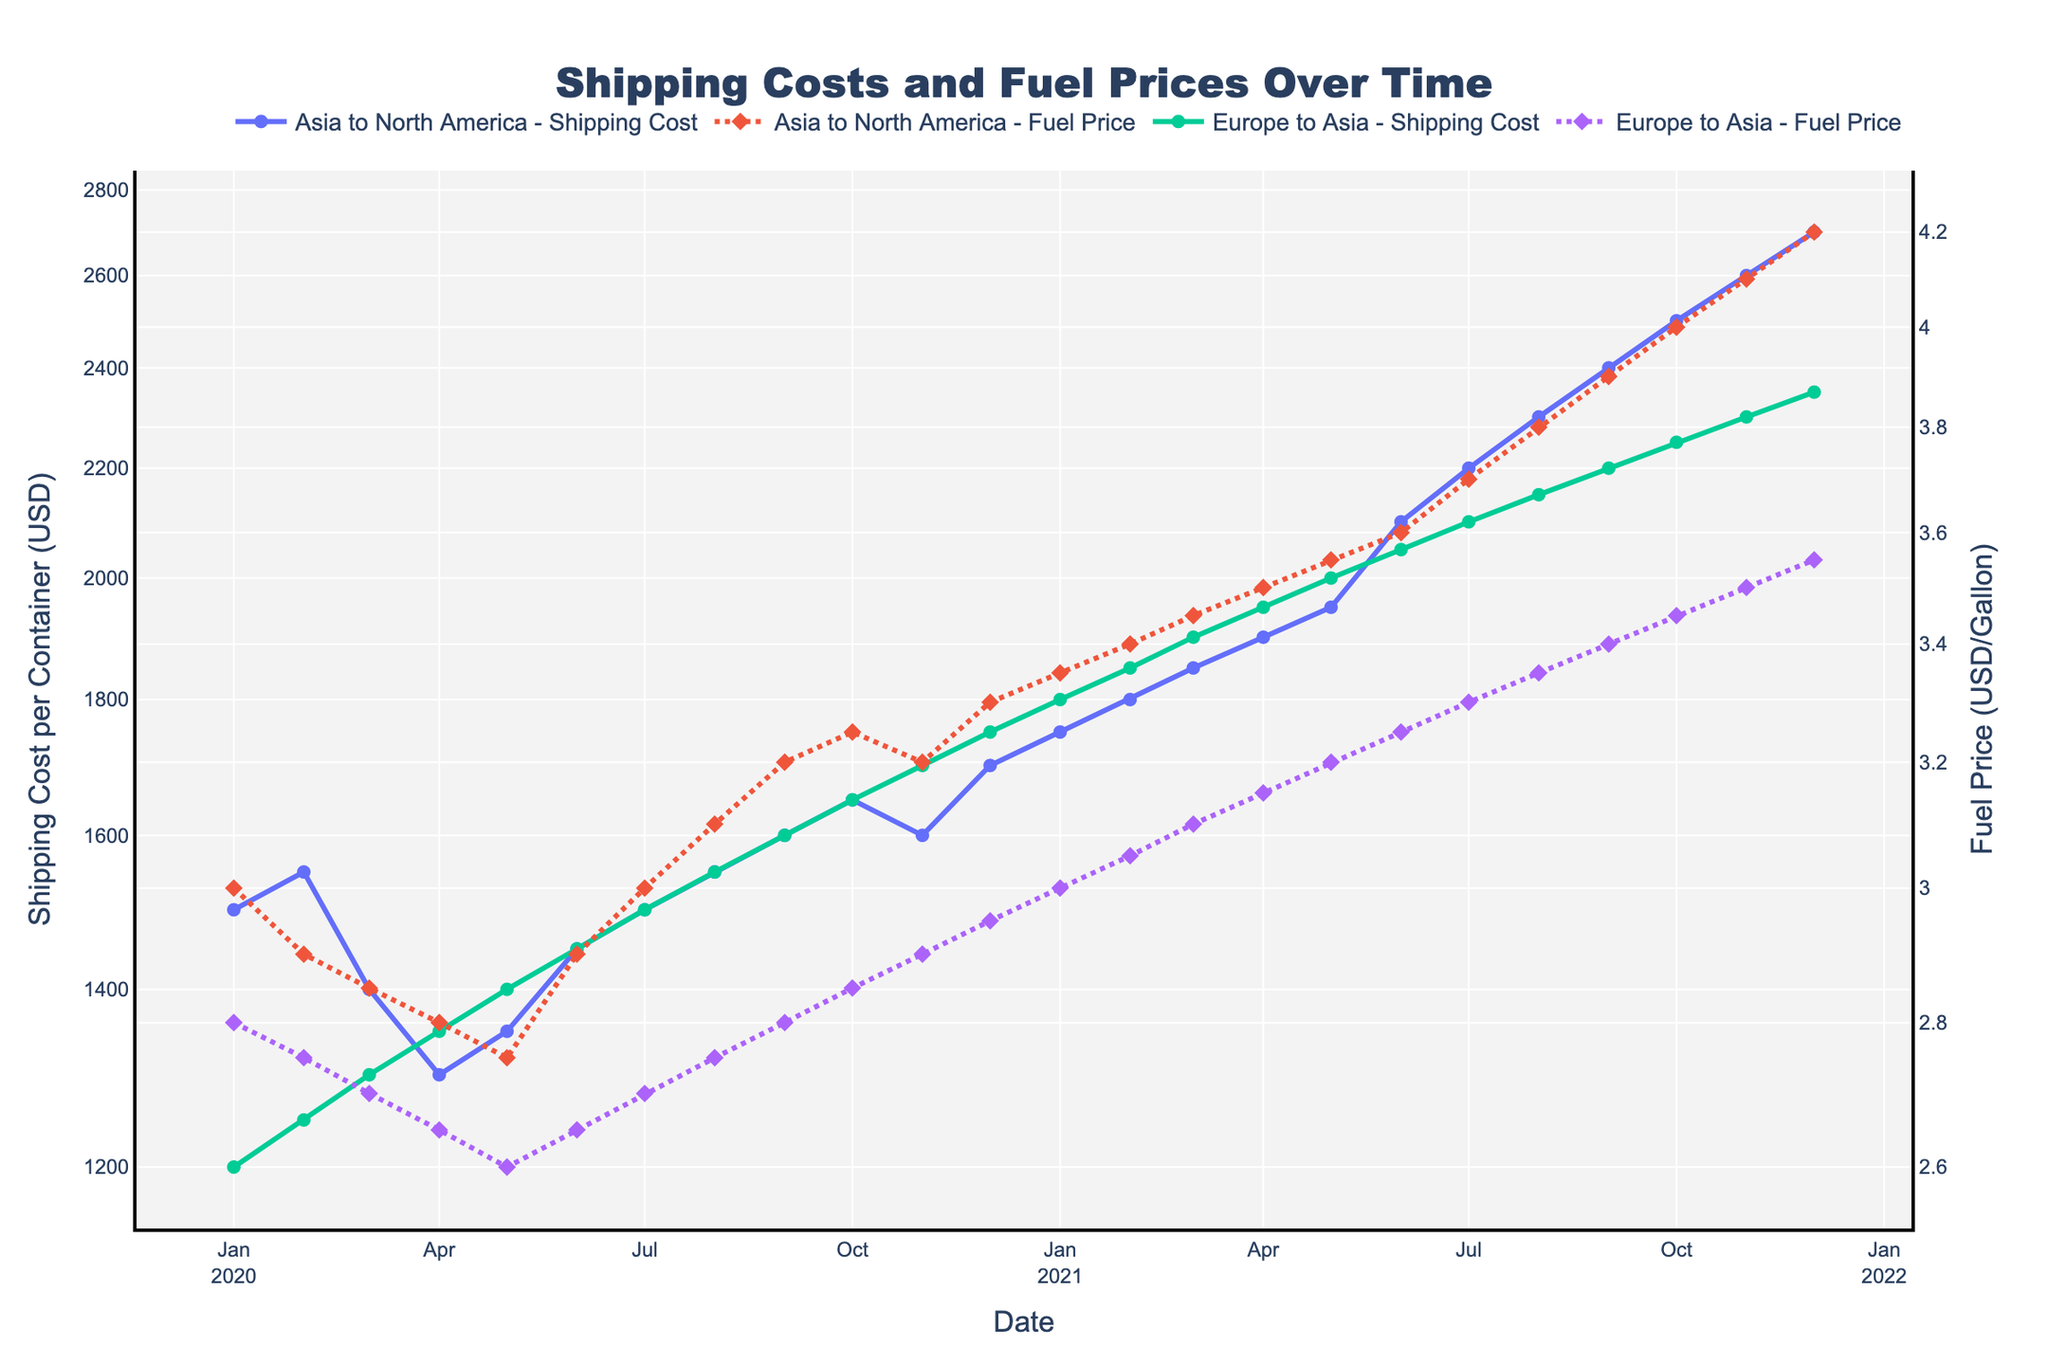What's the title of the figure? The title is displayed at the top of the figure. The text is clear and prominent, located in the middle and reads "Shipping Costs and Fuel Prices Over Time".
Answer: Shipping Costs and Fuel Prices Over Time Which axis represents the shipping cost per container? The shipping cost per container is shown on the vertical (y) axis on the left side of the figure. The label "Shipping Cost per Container (USD)" indicates it.
Answer: Left vertical axis How does the fuel price trend compare between the routes "Asia to North America" and "Europe to Asia" over the given period? By observing the dotted lines, which represent fuel prices, we can compare the trends for both routes. Initially, both routes show a gradual increase in fuel prices, but "Asia to North America" shows a steeper increase than "Europe to Asia" from mid-2020 to the end of 2021.
Answer: Steeper increase for "Asia to North America" At which point did the shipping cost for "Asia to North America" exceed $2000? By tracing the solid line for "Asia to North America," it is clear that the shipping cost exceeded $2000 in June 2021. This is visible where the data points surpass the $2000 mark on the y-axis.
Answer: June 2021 What is the shipping cost difference between "Asia to North America" and "Europe to Asia" at the end of 2021? By locating the December 2021 data points for both routes, it can be seen that the shipping cost for "Asia to North America" is $2700, and for "Europe to Asia," it is $2350. The difference is $2700 - $2350.
Answer: $350 Which route shows a more variable shipping cost trend over the period? Both routes' solid lines are inspected. "Asia to North America" shows more pronounced fluctuations and a greater increase in shipping costs, making its trend appear more variable compared to "Europe to Asia".
Answer: Asia to North America Between January 2020 and January 2021, how did the change in fuel price for "Europe to Asia" affect the shipping cost? From January 2020 to January 2021, the fuel price for "Europe to Asia" increased from $2.80 to $3.00. Correspondingly, the shipping cost rose from $1200 to $1800. This reflects the impact of fuel price increases on shipping costs.
Answer: Increased shipping cost 